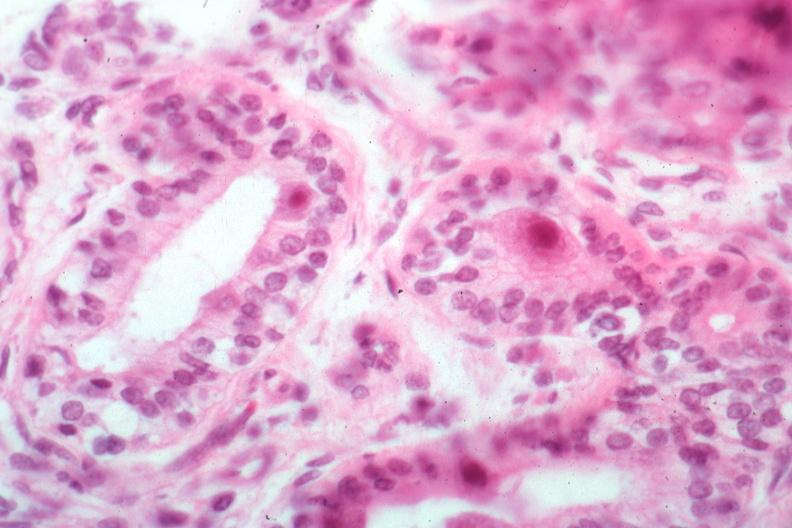s cytomegalovirus present?
Answer the question using a single word or phrase. Yes 